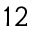Convert formula to latex. <formula><loc_0><loc_0><loc_500><loc_500>1 2</formula> 